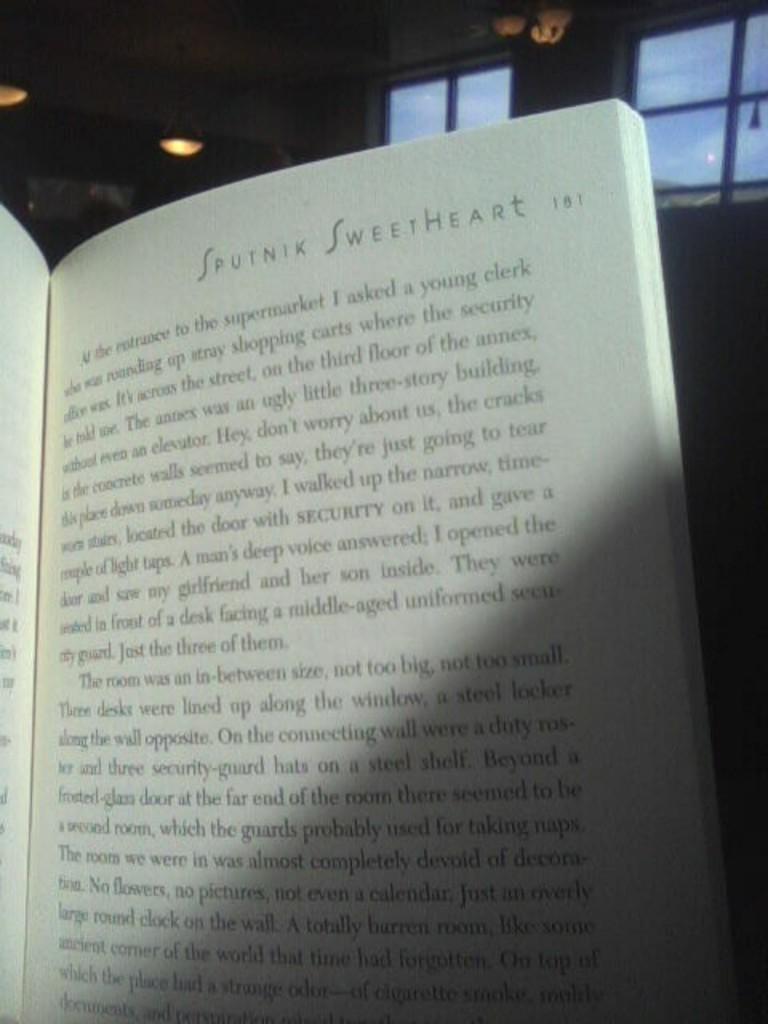Is this a children's book?
Give a very brief answer. Unanswerable. 